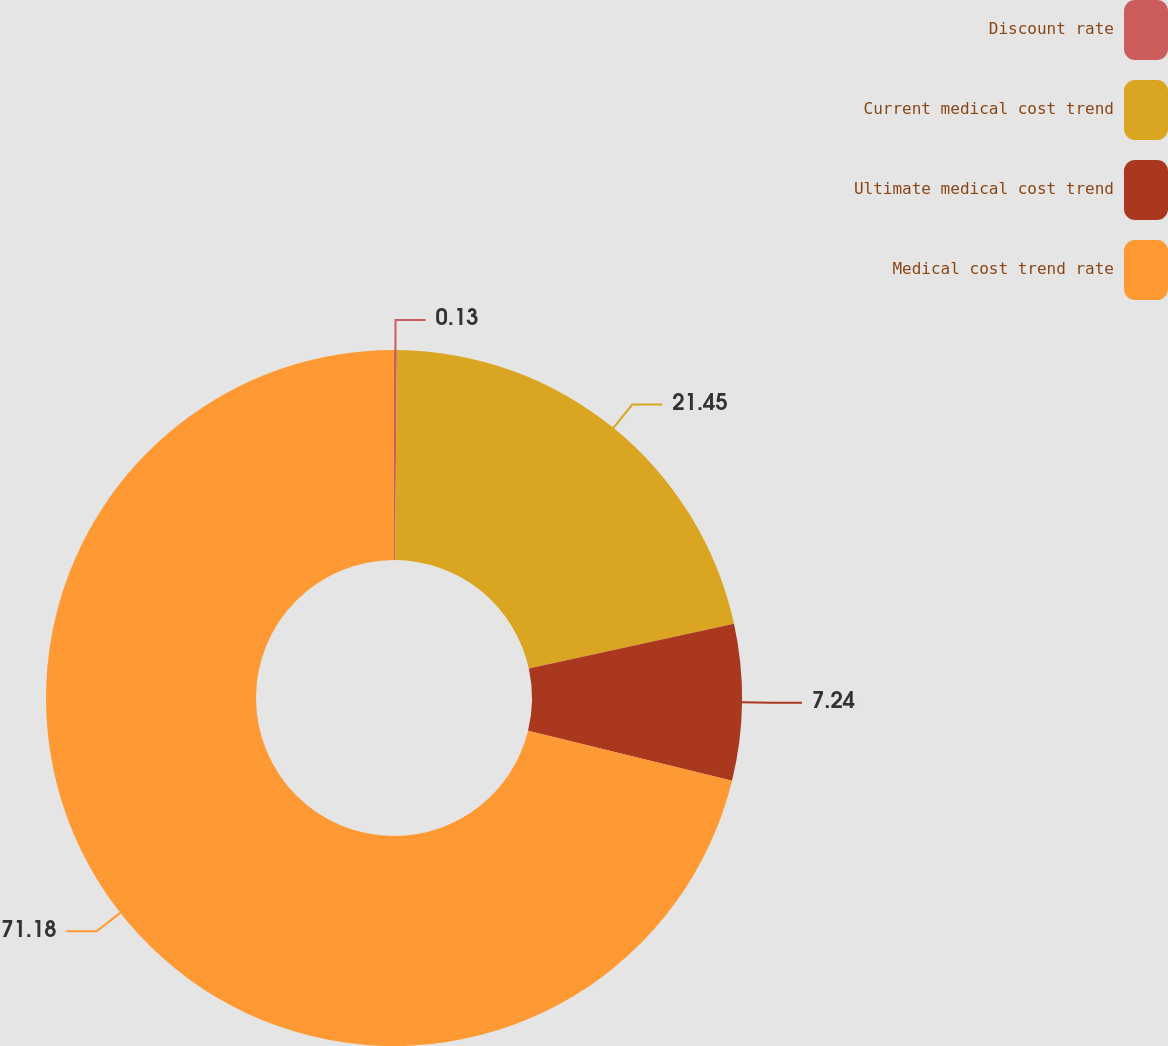<chart> <loc_0><loc_0><loc_500><loc_500><pie_chart><fcel>Discount rate<fcel>Current medical cost trend<fcel>Ultimate medical cost trend<fcel>Medical cost trend rate<nl><fcel>0.13%<fcel>21.45%<fcel>7.24%<fcel>71.18%<nl></chart> 